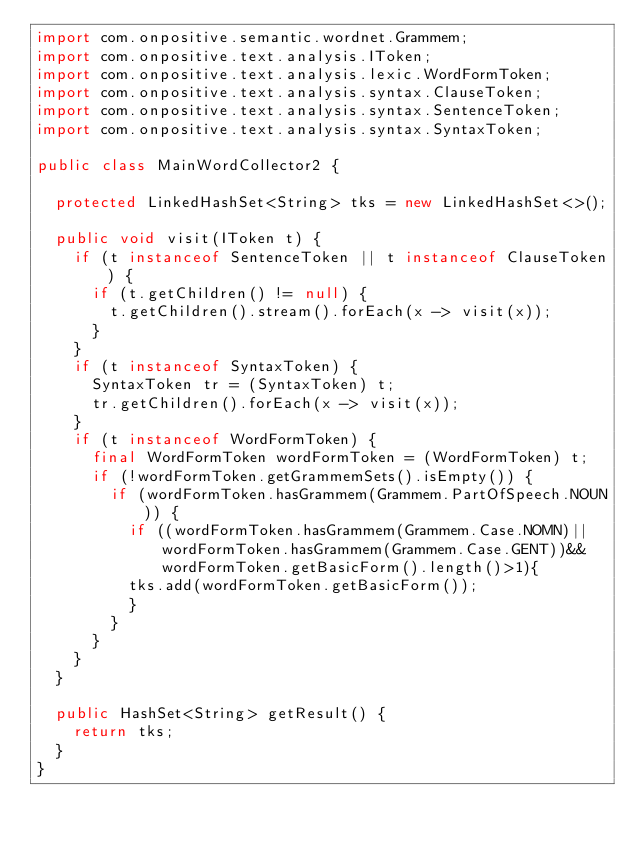<code> <loc_0><loc_0><loc_500><loc_500><_Java_>import com.onpositive.semantic.wordnet.Grammem;
import com.onpositive.text.analysis.IToken;
import com.onpositive.text.analysis.lexic.WordFormToken;
import com.onpositive.text.analysis.syntax.ClauseToken;
import com.onpositive.text.analysis.syntax.SentenceToken;
import com.onpositive.text.analysis.syntax.SyntaxToken;

public class MainWordCollector2 {

	protected LinkedHashSet<String> tks = new LinkedHashSet<>();

	public void visit(IToken t) {
		if (t instanceof SentenceToken || t instanceof ClauseToken) {
			if (t.getChildren() != null) {
				t.getChildren().stream().forEach(x -> visit(x));
			}
		}
		if (t instanceof SyntaxToken) {
			SyntaxToken tr = (SyntaxToken) t;
			tr.getChildren().forEach(x -> visit(x));
		}
		if (t instanceof WordFormToken) {
			final WordFormToken wordFormToken = (WordFormToken) t;
			if (!wordFormToken.getGrammemSets().isEmpty()) {
				if (wordFormToken.hasGrammem(Grammem.PartOfSpeech.NOUN)) {
					if ((wordFormToken.hasGrammem(Grammem.Case.NOMN)||wordFormToken.hasGrammem(Grammem.Case.GENT))&&wordFormToken.getBasicForm().length()>1){
					tks.add(wordFormToken.getBasicForm());
					}
				}
			}
		}
	}

	public HashSet<String> getResult() {
		return tks;
	}
}
</code> 